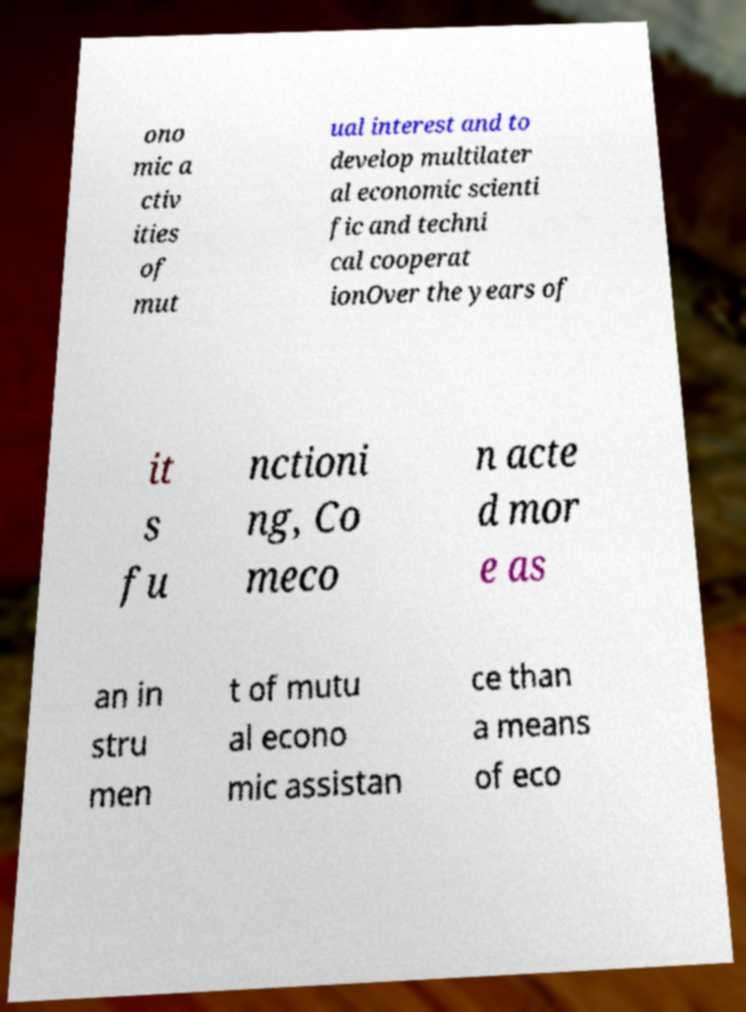Can you read and provide the text displayed in the image?This photo seems to have some interesting text. Can you extract and type it out for me? ono mic a ctiv ities of mut ual interest and to develop multilater al economic scienti fic and techni cal cooperat ionOver the years of it s fu nctioni ng, Co meco n acte d mor e as an in stru men t of mutu al econo mic assistan ce than a means of eco 